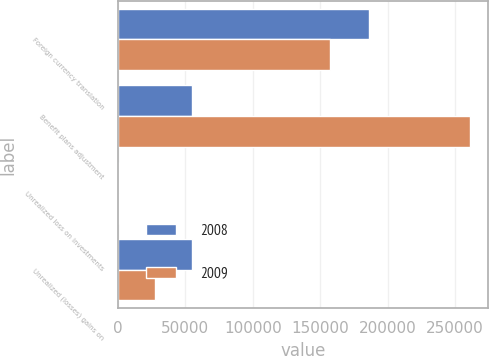Convert chart. <chart><loc_0><loc_0><loc_500><loc_500><stacked_bar_chart><ecel><fcel>Foreign currency translation<fcel>Benefit plans adjustment<fcel>Unrealized loss on investments<fcel>Unrealized (losses) gains on<nl><fcel>2008<fcel>186447<fcel>54593<fcel>581<fcel>54593<nl><fcel>2009<fcel>157089<fcel>261457<fcel>622<fcel>27480<nl></chart> 